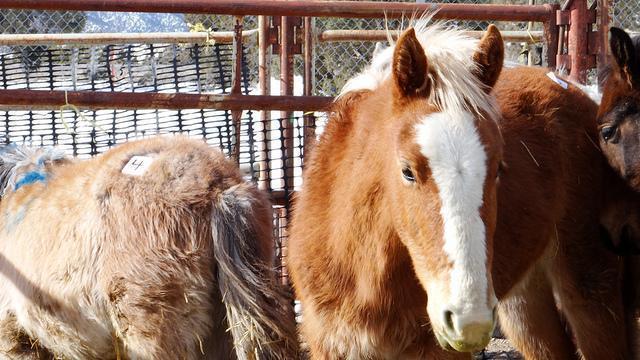What kind of races does this animal run?
Choose the right answer and clarify with the format: 'Answer: answer
Rationale: rationale.'
Options: Car, three legged, derby, plane. Answer: derby.
Rationale: The animals visible are horses based on their visible features. these animals are known to compete in races called answer a. 